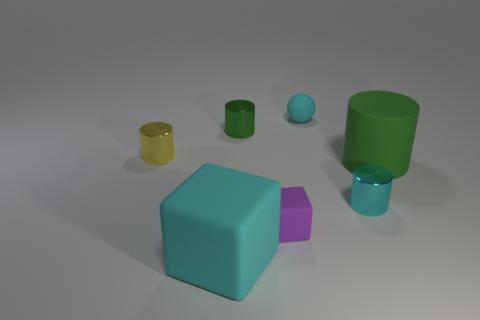The matte ball has what color?
Your response must be concise. Cyan. What color is the rubber block that is the same size as the green matte cylinder?
Offer a terse response. Cyan. There is a big rubber object on the left side of the big green rubber cylinder; is it the same shape as the yellow shiny thing?
Your response must be concise. No. The big thing on the left side of the green object right of the small metallic object on the right side of the tiny matte sphere is what color?
Your response must be concise. Cyan. Are there any tiny green metallic blocks?
Make the answer very short. No. What number of other things are there of the same size as the green shiny cylinder?
Your answer should be very brief. 4. Is the color of the small matte sphere the same as the tiny metal cylinder that is in front of the small yellow shiny cylinder?
Provide a succinct answer. Yes. What number of objects are either blue metallic things or small green cylinders?
Offer a terse response. 1. Are there any other things that have the same color as the rubber ball?
Your response must be concise. Yes. Do the yellow cylinder and the green object right of the cyan ball have the same material?
Make the answer very short. No. 